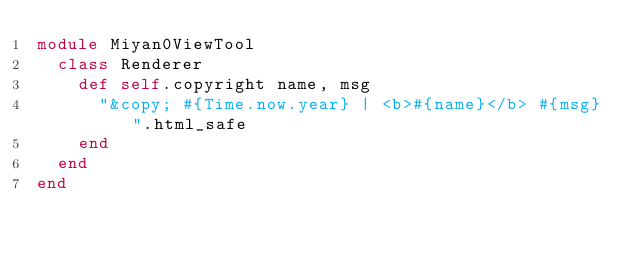<code> <loc_0><loc_0><loc_500><loc_500><_Ruby_>module Miyan0ViewTool
  class Renderer
    def self.copyright name, msg
      "&copy; #{Time.now.year} | <b>#{name}</b> #{msg}".html_safe
    end
  end
end</code> 